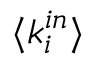Convert formula to latex. <formula><loc_0><loc_0><loc_500><loc_500>\langle k _ { i } ^ { i n } \rangle</formula> 